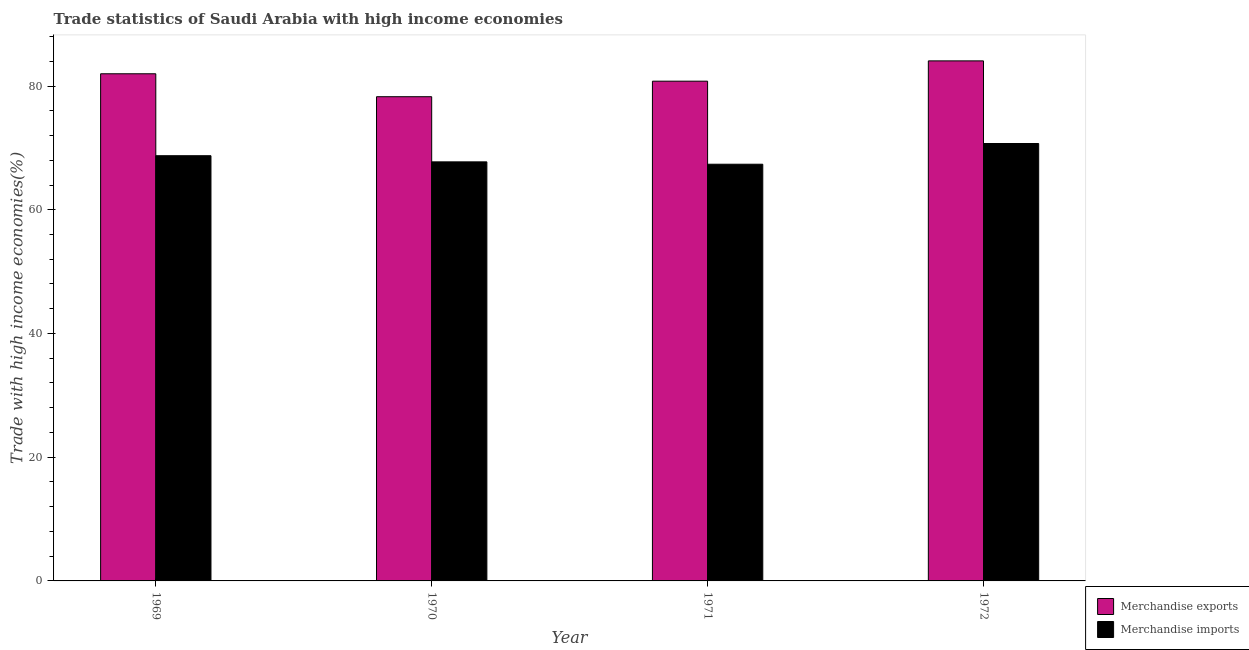How many different coloured bars are there?
Provide a succinct answer. 2. What is the label of the 4th group of bars from the left?
Your response must be concise. 1972. In how many cases, is the number of bars for a given year not equal to the number of legend labels?
Provide a short and direct response. 0. What is the merchandise exports in 1970?
Ensure brevity in your answer.  78.27. Across all years, what is the maximum merchandise exports?
Offer a very short reply. 84.07. Across all years, what is the minimum merchandise imports?
Offer a terse response. 67.36. In which year was the merchandise imports maximum?
Make the answer very short. 1972. In which year was the merchandise exports minimum?
Give a very brief answer. 1970. What is the total merchandise imports in the graph?
Ensure brevity in your answer.  274.55. What is the difference between the merchandise imports in 1970 and that in 1972?
Give a very brief answer. -2.97. What is the difference between the merchandise exports in 1971 and the merchandise imports in 1970?
Your response must be concise. 2.51. What is the average merchandise imports per year?
Provide a succinct answer. 68.64. In how many years, is the merchandise exports greater than 48 %?
Make the answer very short. 4. What is the ratio of the merchandise imports in 1970 to that in 1972?
Give a very brief answer. 0.96. Is the difference between the merchandise exports in 1970 and 1972 greater than the difference between the merchandise imports in 1970 and 1972?
Ensure brevity in your answer.  No. What is the difference between the highest and the second highest merchandise exports?
Keep it short and to the point. 2.08. What is the difference between the highest and the lowest merchandise exports?
Your answer should be compact. 5.79. What does the 1st bar from the right in 1972 represents?
Offer a very short reply. Merchandise imports. How many bars are there?
Your response must be concise. 8. How many years are there in the graph?
Keep it short and to the point. 4. Are the values on the major ticks of Y-axis written in scientific E-notation?
Ensure brevity in your answer.  No. Does the graph contain grids?
Your answer should be compact. No. How many legend labels are there?
Offer a terse response. 2. What is the title of the graph?
Ensure brevity in your answer.  Trade statistics of Saudi Arabia with high income economies. Does "Private credit bureau" appear as one of the legend labels in the graph?
Make the answer very short. No. What is the label or title of the Y-axis?
Your response must be concise. Trade with high income economies(%). What is the Trade with high income economies(%) of Merchandise exports in 1969?
Your answer should be compact. 81.98. What is the Trade with high income economies(%) in Merchandise imports in 1969?
Give a very brief answer. 68.74. What is the Trade with high income economies(%) in Merchandise exports in 1970?
Ensure brevity in your answer.  78.27. What is the Trade with high income economies(%) in Merchandise imports in 1970?
Your answer should be very brief. 67.74. What is the Trade with high income economies(%) of Merchandise exports in 1971?
Offer a terse response. 80.78. What is the Trade with high income economies(%) in Merchandise imports in 1971?
Make the answer very short. 67.36. What is the Trade with high income economies(%) in Merchandise exports in 1972?
Your answer should be compact. 84.07. What is the Trade with high income economies(%) in Merchandise imports in 1972?
Offer a terse response. 70.71. Across all years, what is the maximum Trade with high income economies(%) of Merchandise exports?
Your answer should be compact. 84.07. Across all years, what is the maximum Trade with high income economies(%) of Merchandise imports?
Make the answer very short. 70.71. Across all years, what is the minimum Trade with high income economies(%) in Merchandise exports?
Provide a short and direct response. 78.27. Across all years, what is the minimum Trade with high income economies(%) in Merchandise imports?
Provide a short and direct response. 67.36. What is the total Trade with high income economies(%) in Merchandise exports in the graph?
Offer a terse response. 325.11. What is the total Trade with high income economies(%) of Merchandise imports in the graph?
Keep it short and to the point. 274.55. What is the difference between the Trade with high income economies(%) of Merchandise exports in 1969 and that in 1970?
Ensure brevity in your answer.  3.71. What is the difference between the Trade with high income economies(%) in Merchandise imports in 1969 and that in 1970?
Give a very brief answer. 0.99. What is the difference between the Trade with high income economies(%) in Merchandise exports in 1969 and that in 1971?
Your answer should be compact. 1.2. What is the difference between the Trade with high income economies(%) in Merchandise imports in 1969 and that in 1971?
Offer a terse response. 1.38. What is the difference between the Trade with high income economies(%) of Merchandise exports in 1969 and that in 1972?
Give a very brief answer. -2.08. What is the difference between the Trade with high income economies(%) of Merchandise imports in 1969 and that in 1972?
Provide a succinct answer. -1.97. What is the difference between the Trade with high income economies(%) of Merchandise exports in 1970 and that in 1971?
Provide a succinct answer. -2.51. What is the difference between the Trade with high income economies(%) in Merchandise imports in 1970 and that in 1971?
Provide a short and direct response. 0.38. What is the difference between the Trade with high income economies(%) in Merchandise exports in 1970 and that in 1972?
Provide a short and direct response. -5.79. What is the difference between the Trade with high income economies(%) of Merchandise imports in 1970 and that in 1972?
Offer a terse response. -2.97. What is the difference between the Trade with high income economies(%) in Merchandise exports in 1971 and that in 1972?
Your answer should be compact. -3.28. What is the difference between the Trade with high income economies(%) in Merchandise imports in 1971 and that in 1972?
Ensure brevity in your answer.  -3.35. What is the difference between the Trade with high income economies(%) in Merchandise exports in 1969 and the Trade with high income economies(%) in Merchandise imports in 1970?
Give a very brief answer. 14.24. What is the difference between the Trade with high income economies(%) in Merchandise exports in 1969 and the Trade with high income economies(%) in Merchandise imports in 1971?
Provide a short and direct response. 14.62. What is the difference between the Trade with high income economies(%) of Merchandise exports in 1969 and the Trade with high income economies(%) of Merchandise imports in 1972?
Your response must be concise. 11.27. What is the difference between the Trade with high income economies(%) in Merchandise exports in 1970 and the Trade with high income economies(%) in Merchandise imports in 1971?
Your answer should be very brief. 10.91. What is the difference between the Trade with high income economies(%) of Merchandise exports in 1970 and the Trade with high income economies(%) of Merchandise imports in 1972?
Provide a succinct answer. 7.57. What is the difference between the Trade with high income economies(%) in Merchandise exports in 1971 and the Trade with high income economies(%) in Merchandise imports in 1972?
Make the answer very short. 10.07. What is the average Trade with high income economies(%) of Merchandise exports per year?
Provide a short and direct response. 81.28. What is the average Trade with high income economies(%) of Merchandise imports per year?
Give a very brief answer. 68.64. In the year 1969, what is the difference between the Trade with high income economies(%) of Merchandise exports and Trade with high income economies(%) of Merchandise imports?
Provide a short and direct response. 13.25. In the year 1970, what is the difference between the Trade with high income economies(%) of Merchandise exports and Trade with high income economies(%) of Merchandise imports?
Make the answer very short. 10.53. In the year 1971, what is the difference between the Trade with high income economies(%) of Merchandise exports and Trade with high income economies(%) of Merchandise imports?
Offer a very short reply. 13.42. In the year 1972, what is the difference between the Trade with high income economies(%) in Merchandise exports and Trade with high income economies(%) in Merchandise imports?
Make the answer very short. 13.36. What is the ratio of the Trade with high income economies(%) in Merchandise exports in 1969 to that in 1970?
Your response must be concise. 1.05. What is the ratio of the Trade with high income economies(%) in Merchandise imports in 1969 to that in 1970?
Your response must be concise. 1.01. What is the ratio of the Trade with high income economies(%) in Merchandise exports in 1969 to that in 1971?
Ensure brevity in your answer.  1.01. What is the ratio of the Trade with high income economies(%) in Merchandise imports in 1969 to that in 1971?
Your response must be concise. 1.02. What is the ratio of the Trade with high income economies(%) of Merchandise exports in 1969 to that in 1972?
Keep it short and to the point. 0.98. What is the ratio of the Trade with high income economies(%) in Merchandise imports in 1969 to that in 1972?
Your answer should be compact. 0.97. What is the ratio of the Trade with high income economies(%) of Merchandise exports in 1970 to that in 1971?
Provide a short and direct response. 0.97. What is the ratio of the Trade with high income economies(%) in Merchandise exports in 1970 to that in 1972?
Keep it short and to the point. 0.93. What is the ratio of the Trade with high income economies(%) of Merchandise imports in 1970 to that in 1972?
Give a very brief answer. 0.96. What is the ratio of the Trade with high income economies(%) of Merchandise exports in 1971 to that in 1972?
Make the answer very short. 0.96. What is the ratio of the Trade with high income economies(%) in Merchandise imports in 1971 to that in 1972?
Give a very brief answer. 0.95. What is the difference between the highest and the second highest Trade with high income economies(%) of Merchandise exports?
Offer a terse response. 2.08. What is the difference between the highest and the second highest Trade with high income economies(%) in Merchandise imports?
Your response must be concise. 1.97. What is the difference between the highest and the lowest Trade with high income economies(%) in Merchandise exports?
Give a very brief answer. 5.79. What is the difference between the highest and the lowest Trade with high income economies(%) of Merchandise imports?
Give a very brief answer. 3.35. 